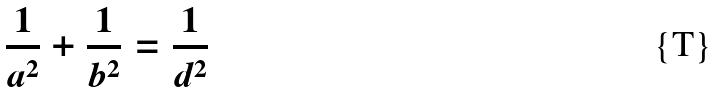<formula> <loc_0><loc_0><loc_500><loc_500>\frac { 1 } { a ^ { 2 } } + \frac { 1 } { b ^ { 2 } } = \frac { 1 } { d ^ { 2 } }</formula> 